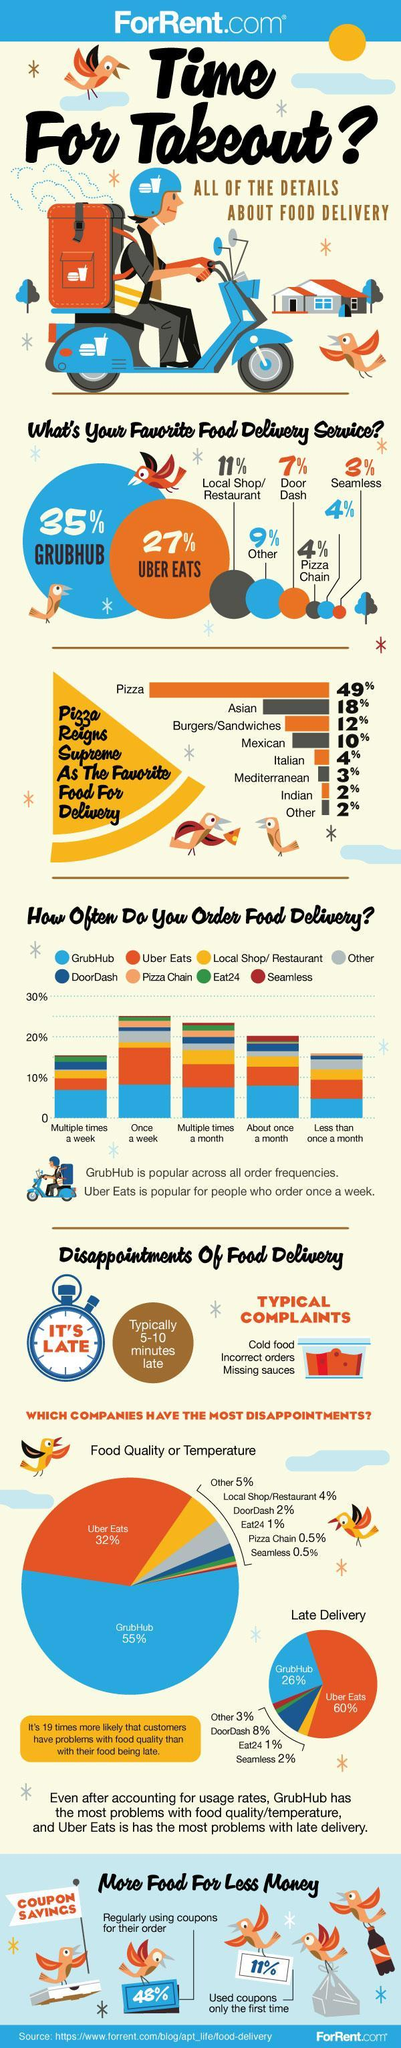What % of consumers use coupons for their first order only
Answer the question with a short phrase. 11% What % of consumers use coupons for their order regularly 48% What is written on the dial of the timer It's Late Wht is the total share in % of Asian and Mexican cuisine in food for delivery 28 What is the colour of the helment, blue or white blue Uber Eats covers what % of the food delivery service 27% What % of food delivery service is covered by grubhub and uber eats 62 What frequency of ordering is more for Seamless About once a month What is the maximum frequency of ordering through Uber Eats Once a week 